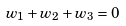<formula> <loc_0><loc_0><loc_500><loc_500>w _ { 1 } + w _ { 2 } + w _ { 3 } = 0</formula> 